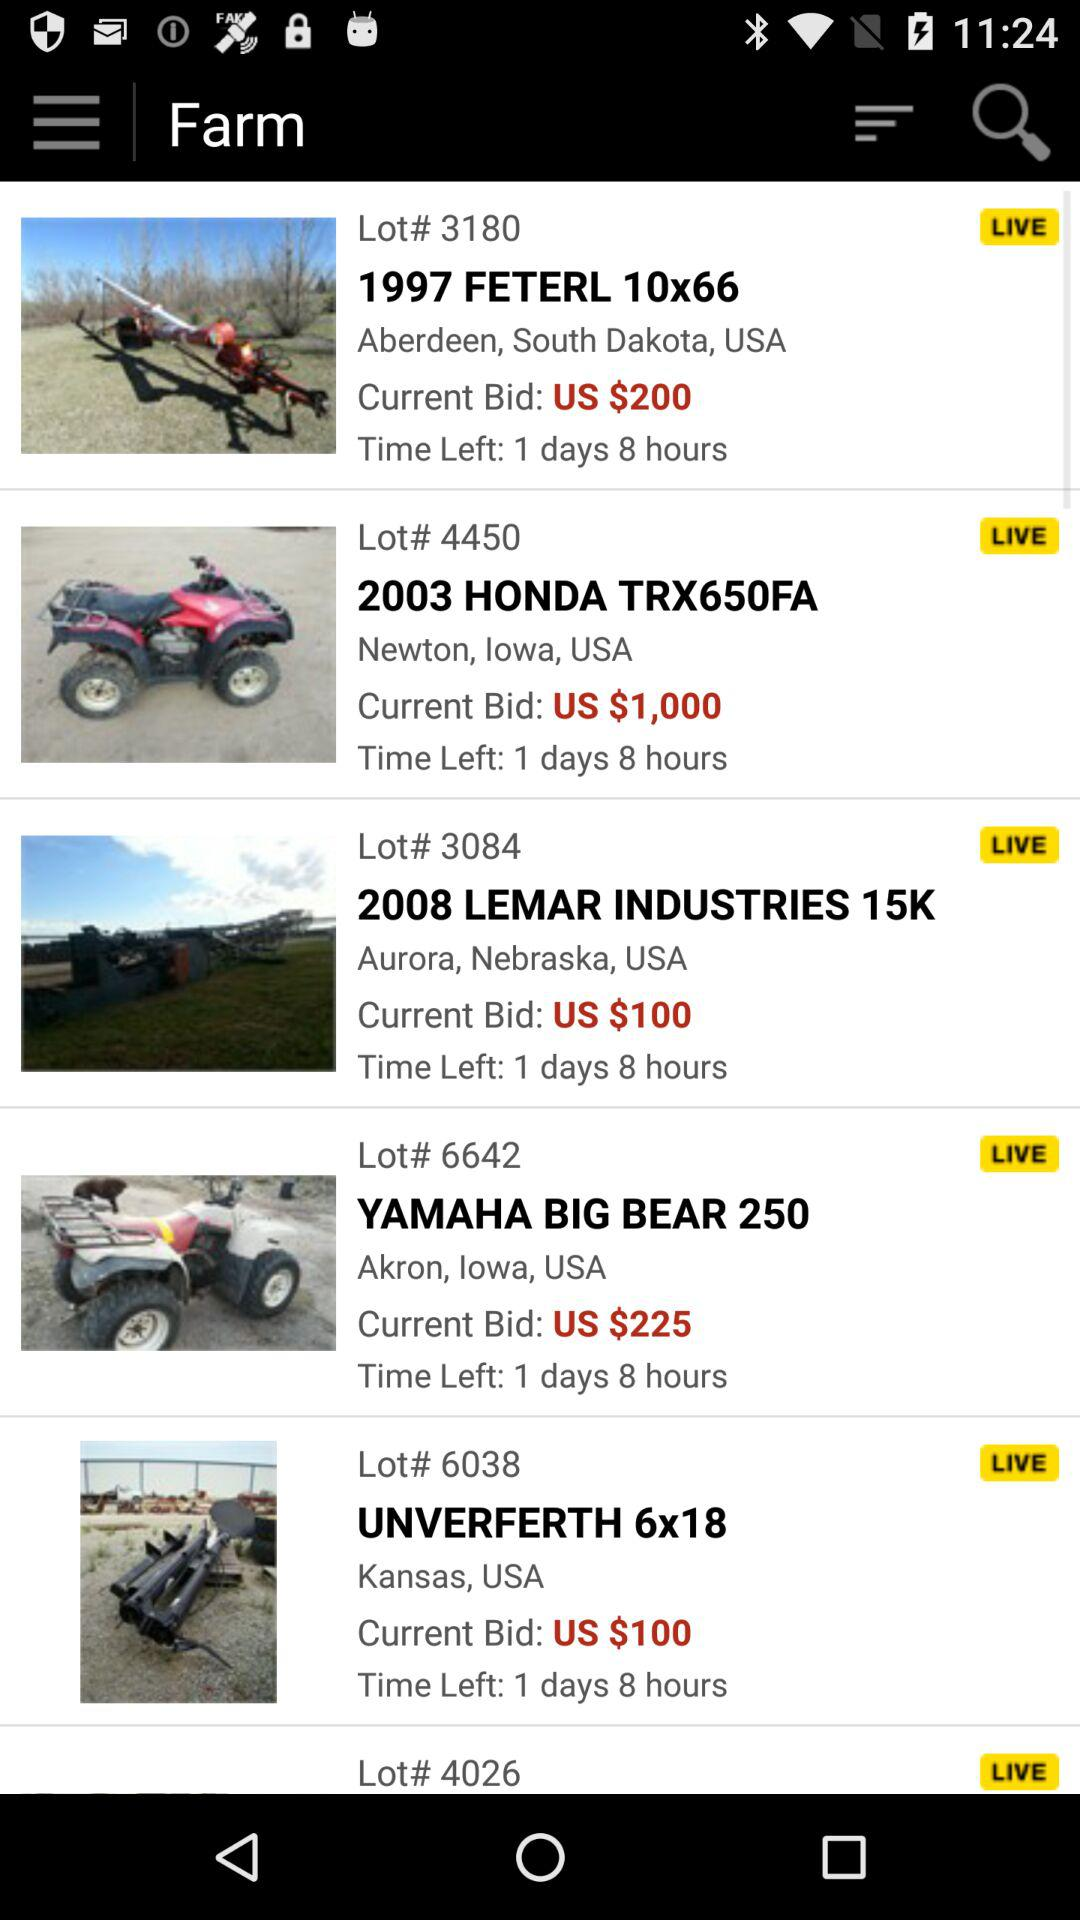What is the location for the 2003 Honda TRX650FA's? The location for the 2003 Honda TRX650FA's is Newton, Iowa, USA. 